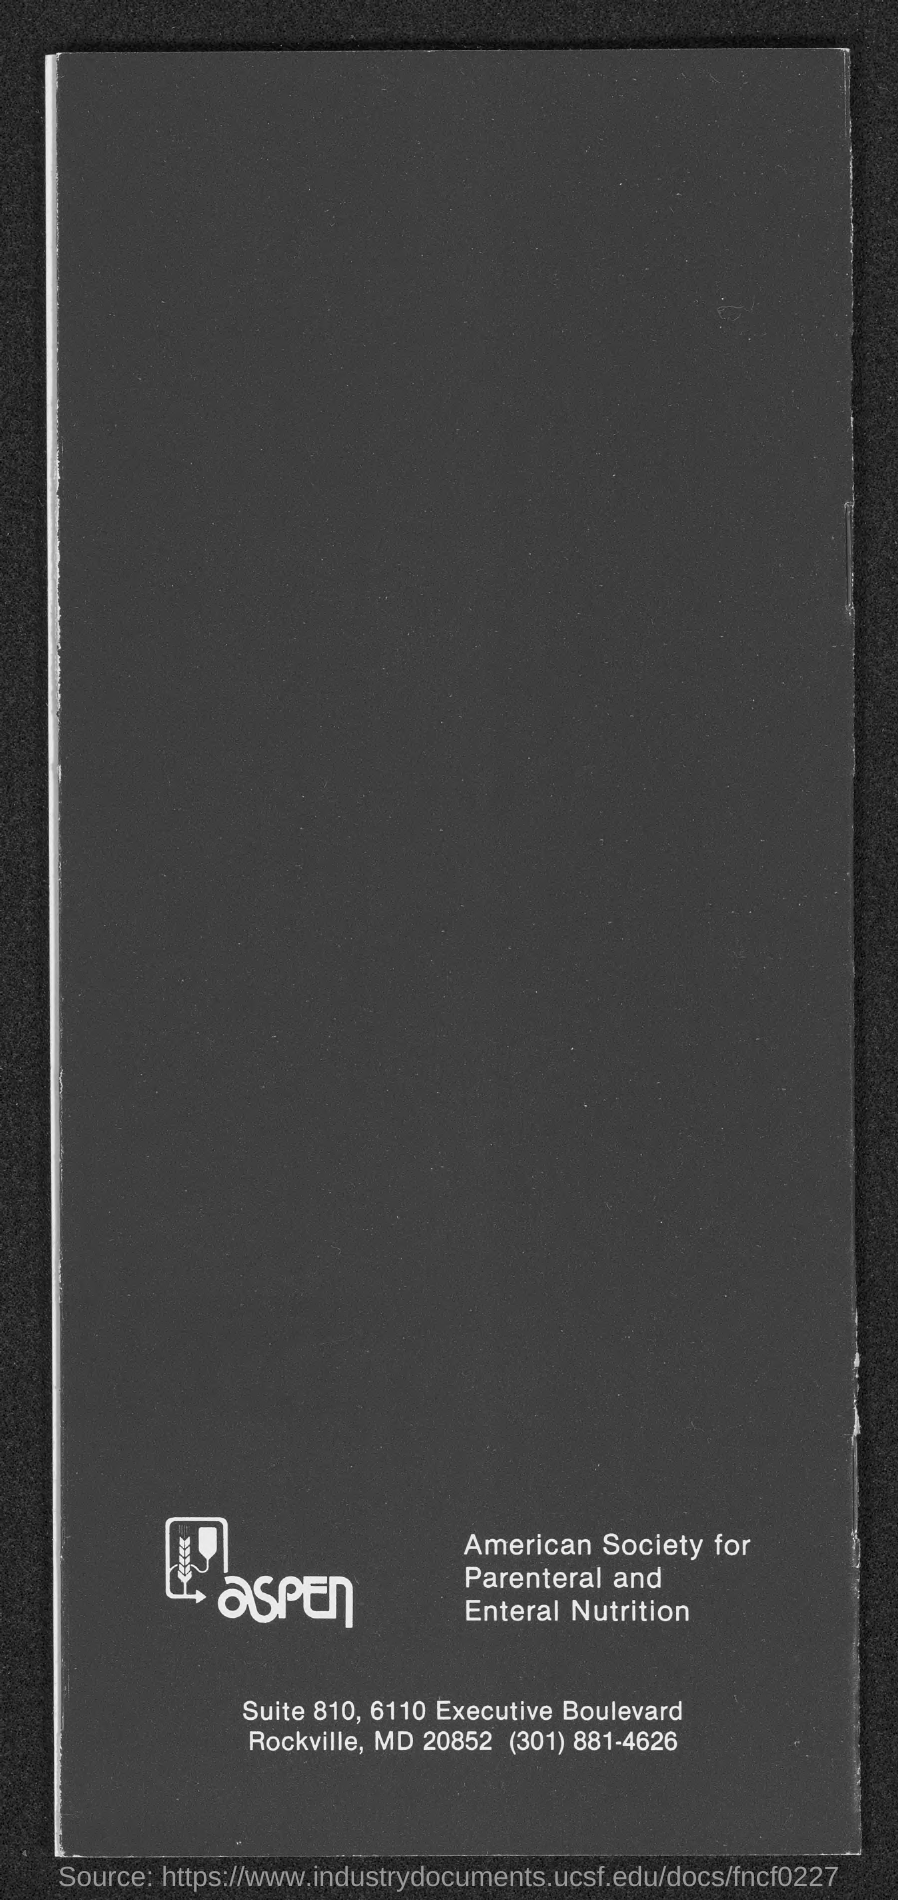What is the street address of american society for parental and enteral nutrition?
Offer a very short reply. Suite 810, 6110 Executive Boulevard. What is the telephone number of american society for parental and enteral nutrition ?
Keep it short and to the point. (301) 881-4626. 